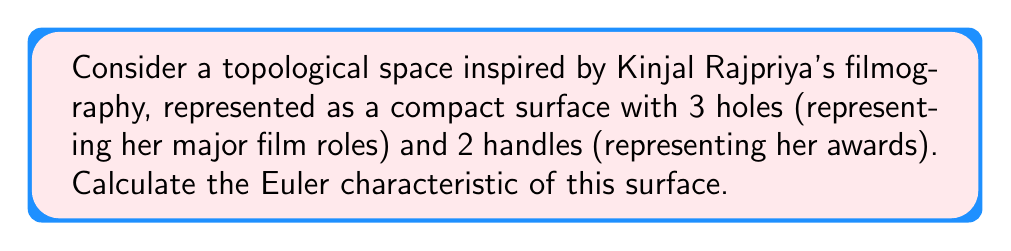Help me with this question. To find the Euler characteristic of this topological space, we'll follow these steps:

1) First, recall the formula for the Euler characteristic $\chi$:

   $$\chi = V - E + F$$

   where $V$ is the number of vertices, $E$ is the number of edges, and $F$ is the number of faces.

2) For a compact surface with $g$ handles and $h$ holes, we can use the alternative formula:

   $$\chi = 2 - 2g - h$$

3) In this case, inspired by Kinjal Rajpriya's filmography:
   - Number of handles, $g = 2$ (representing her awards)
   - Number of holes, $h = 3$ (representing her major film roles)

4) Substituting these values into the formula:

   $$\chi = 2 - 2(2) - 3$$
   $$\chi = 2 - 4 - 3$$
   $$\chi = -5$$

5) Therefore, the Euler characteristic of this topological space is -5.

This negative Euler characteristic indicates that the surface is not a sphere and has a more complex topology, which is fitting for representing the diverse and intricate career of Kinjal Rajpriya.
Answer: $\chi = -5$ 